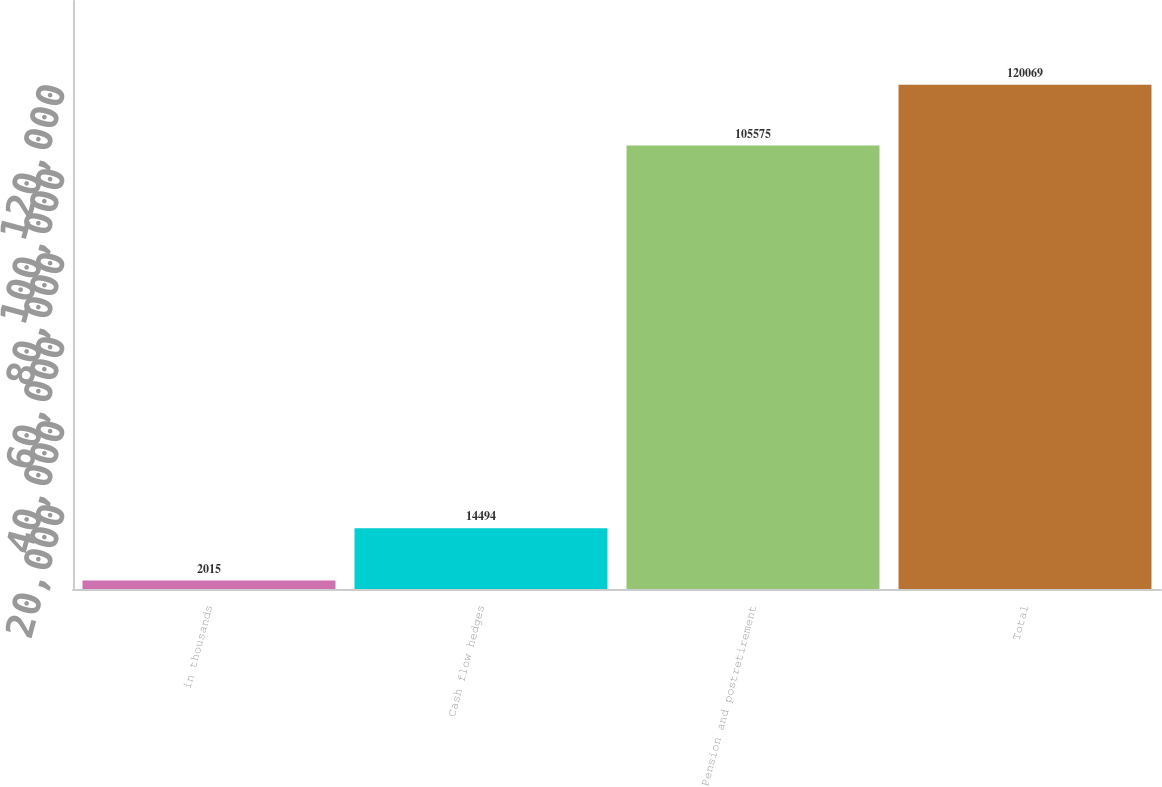<chart> <loc_0><loc_0><loc_500><loc_500><bar_chart><fcel>in thousands<fcel>Cash flow hedges<fcel>Pension and postretirement<fcel>Total<nl><fcel>2015<fcel>14494<fcel>105575<fcel>120069<nl></chart> 